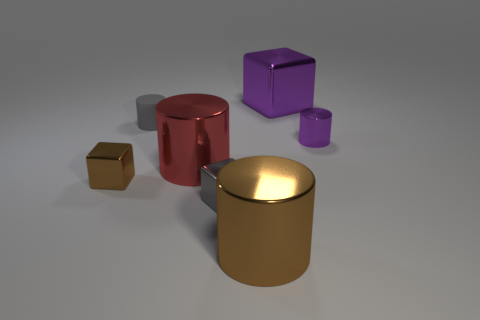Add 1 gray rubber things. How many objects exist? 8 Subtract all green cylinders. Subtract all brown spheres. How many cylinders are left? 4 Subtract all cubes. How many objects are left? 4 Add 3 metallic cubes. How many metallic cubes exist? 6 Subtract 0 blue cylinders. How many objects are left? 7 Subtract all tiny purple cylinders. Subtract all tiny brown metallic things. How many objects are left? 5 Add 7 large brown objects. How many large brown objects are left? 8 